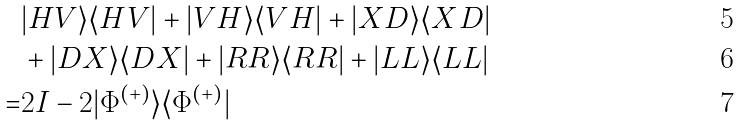<formula> <loc_0><loc_0><loc_500><loc_500>& | H V \rangle \langle H V | + | V H \rangle \langle V H | + | X D \rangle \langle X D | \\ & + | D X \rangle \langle D X | + | R R \rangle \langle R R | + | L L \rangle \langle L L | \\ = & 2 I - 2 | \Phi ^ { ( + ) } \rangle \langle \Phi ^ { ( + ) } |</formula> 